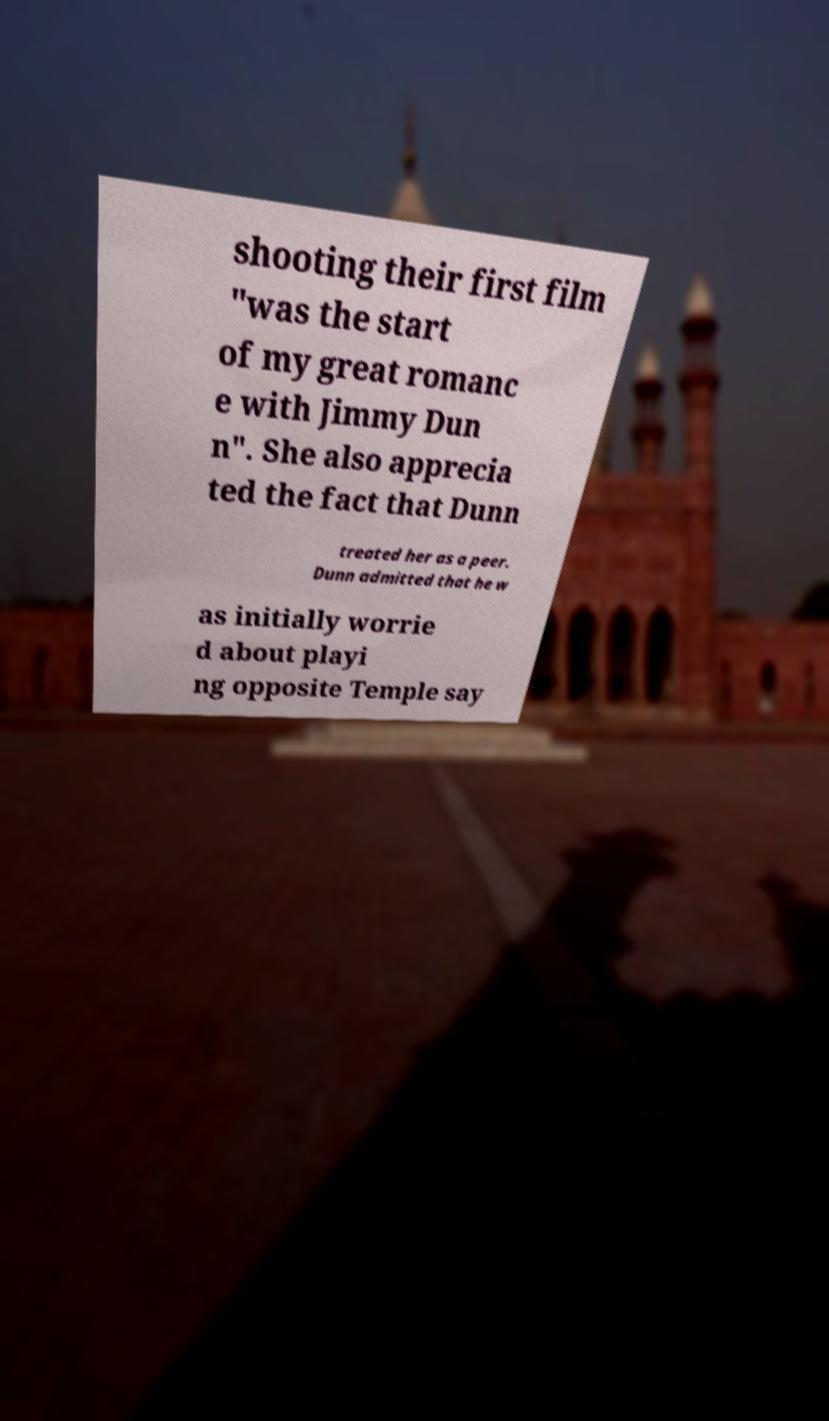For documentation purposes, I need the text within this image transcribed. Could you provide that? shooting their first film "was the start of my great romanc e with Jimmy Dun n". She also apprecia ted the fact that Dunn treated her as a peer. Dunn admitted that he w as initially worrie d about playi ng opposite Temple say 